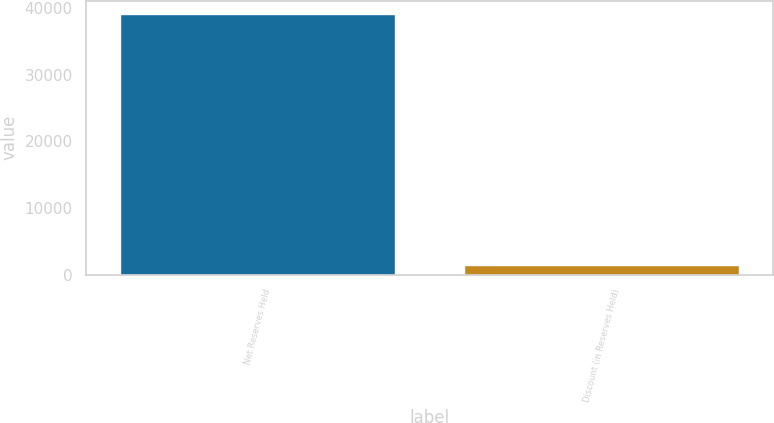Convert chart to OTSL. <chart><loc_0><loc_0><loc_500><loc_500><bar_chart><fcel>Net Reserves Held<fcel>Discount (in Reserves Held)<nl><fcel>39114.9<fcel>1516<nl></chart> 